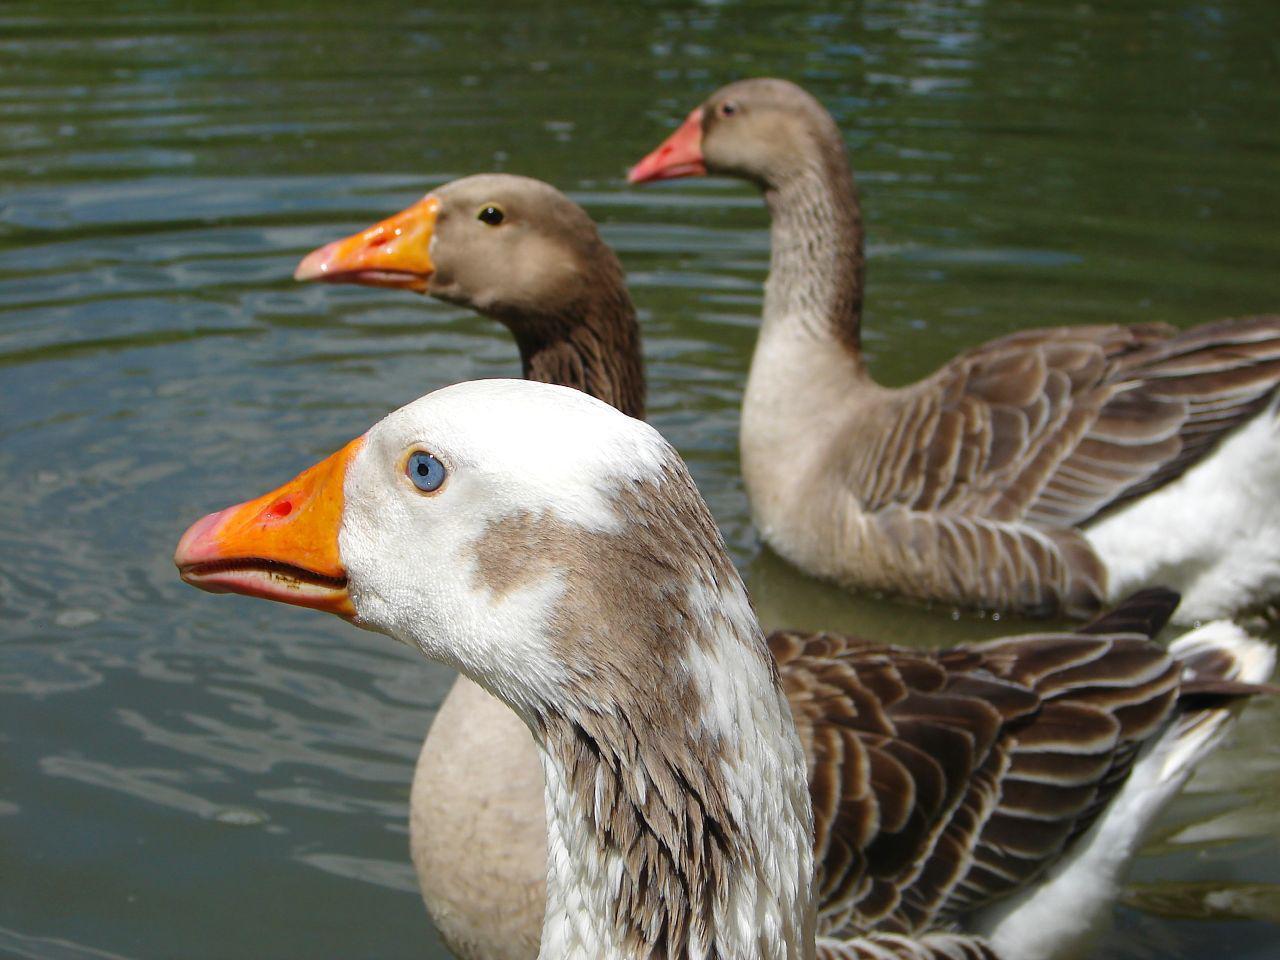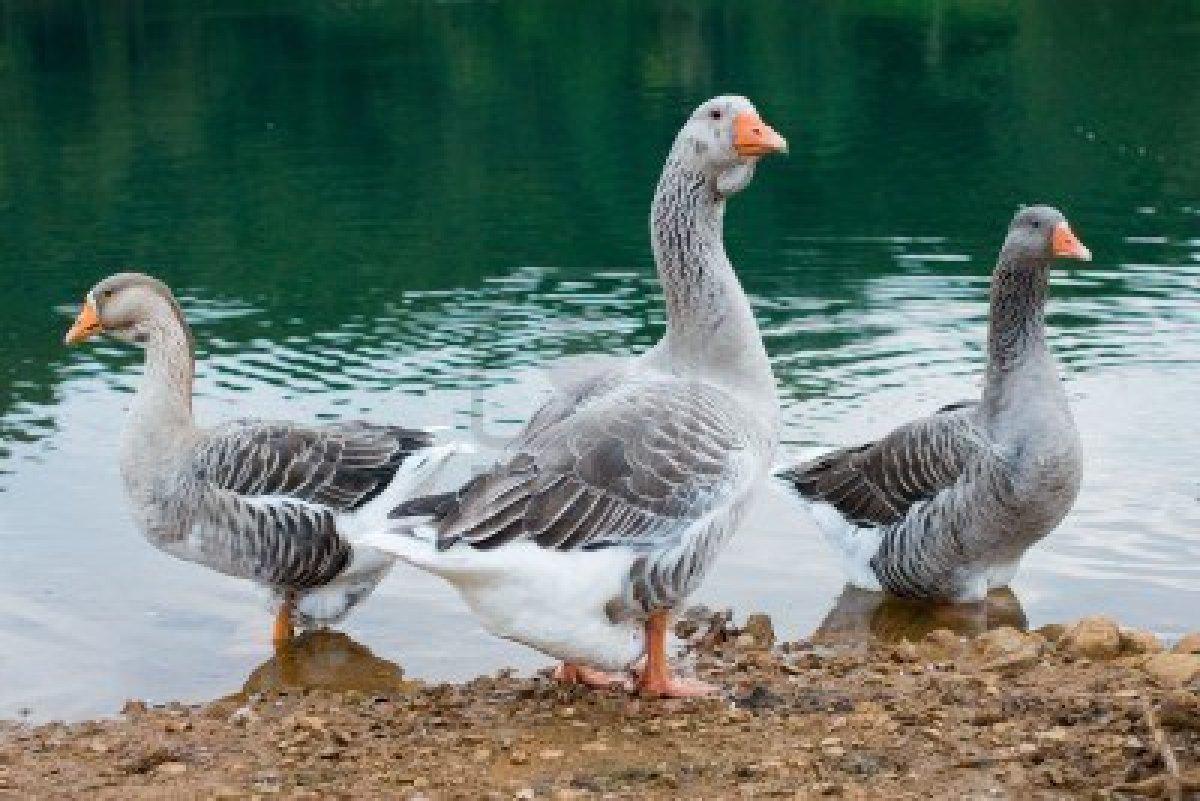The first image is the image on the left, the second image is the image on the right. Assess this claim about the two images: "Three birds float on a pool of water and none of them face leftward, in one image.". Correct or not? Answer yes or no. No. The first image is the image on the left, the second image is the image on the right. Evaluate the accuracy of this statement regarding the images: "In the left image, three geese with orange beaks are floating on water". Is it true? Answer yes or no. Yes. 